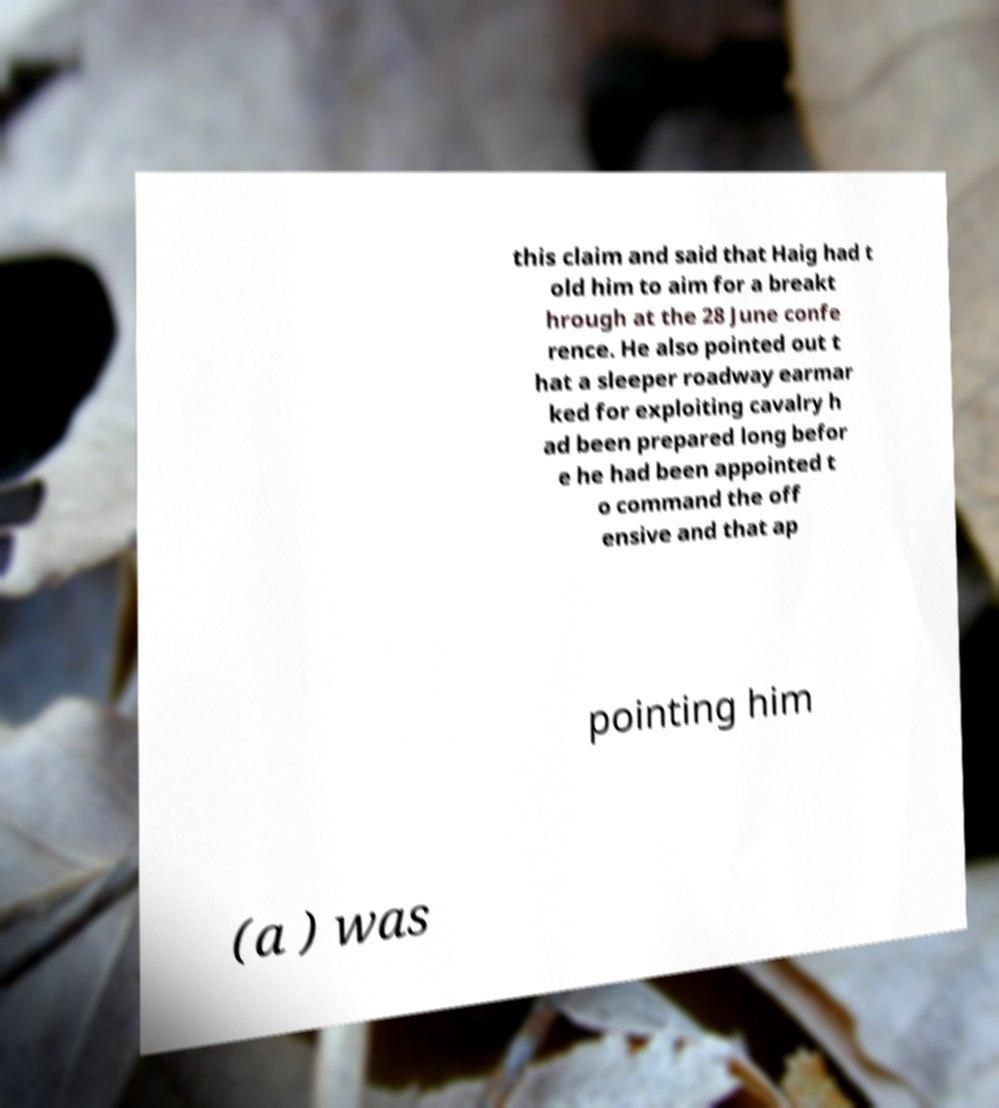Please identify and transcribe the text found in this image. this claim and said that Haig had t old him to aim for a breakt hrough at the 28 June confe rence. He also pointed out t hat a sleeper roadway earmar ked for exploiting cavalry h ad been prepared long befor e he had been appointed t o command the off ensive and that ap pointing him (a ) was 